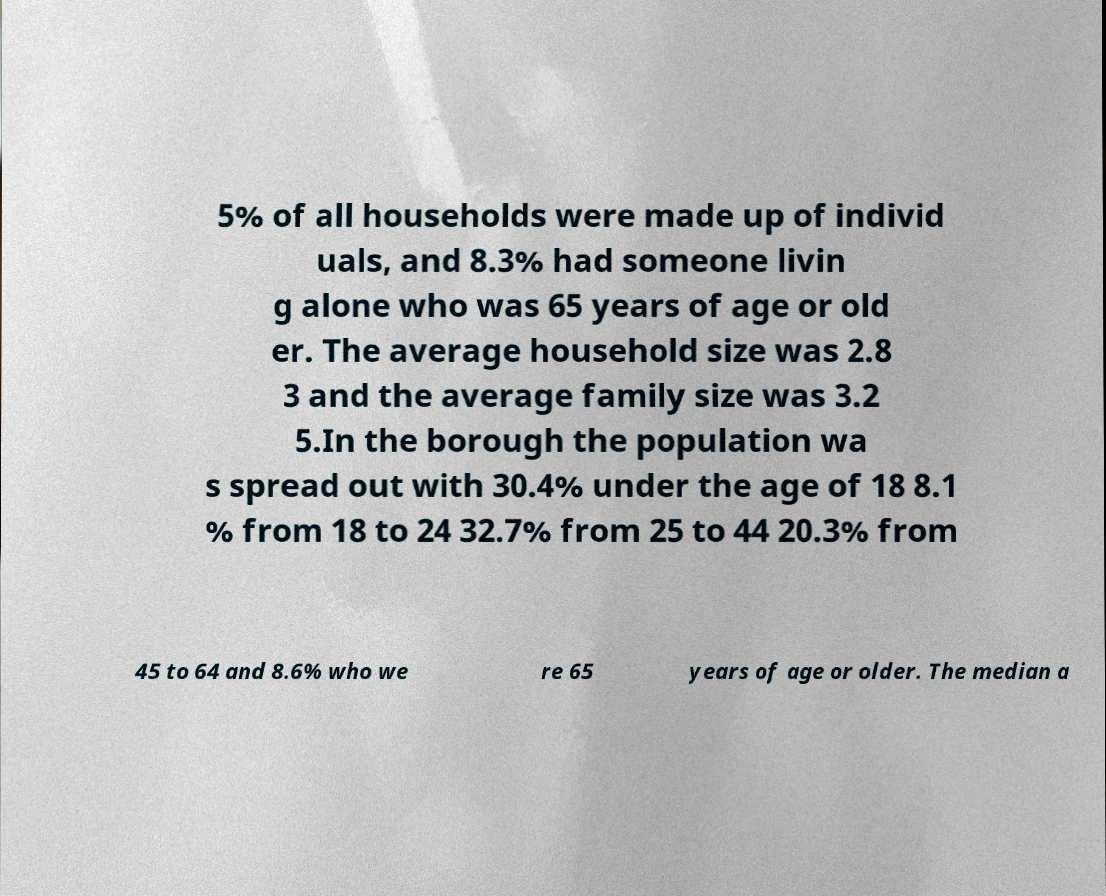Can you accurately transcribe the text from the provided image for me? 5% of all households were made up of individ uals, and 8.3% had someone livin g alone who was 65 years of age or old er. The average household size was 2.8 3 and the average family size was 3.2 5.In the borough the population wa s spread out with 30.4% under the age of 18 8.1 % from 18 to 24 32.7% from 25 to 44 20.3% from 45 to 64 and 8.6% who we re 65 years of age or older. The median a 